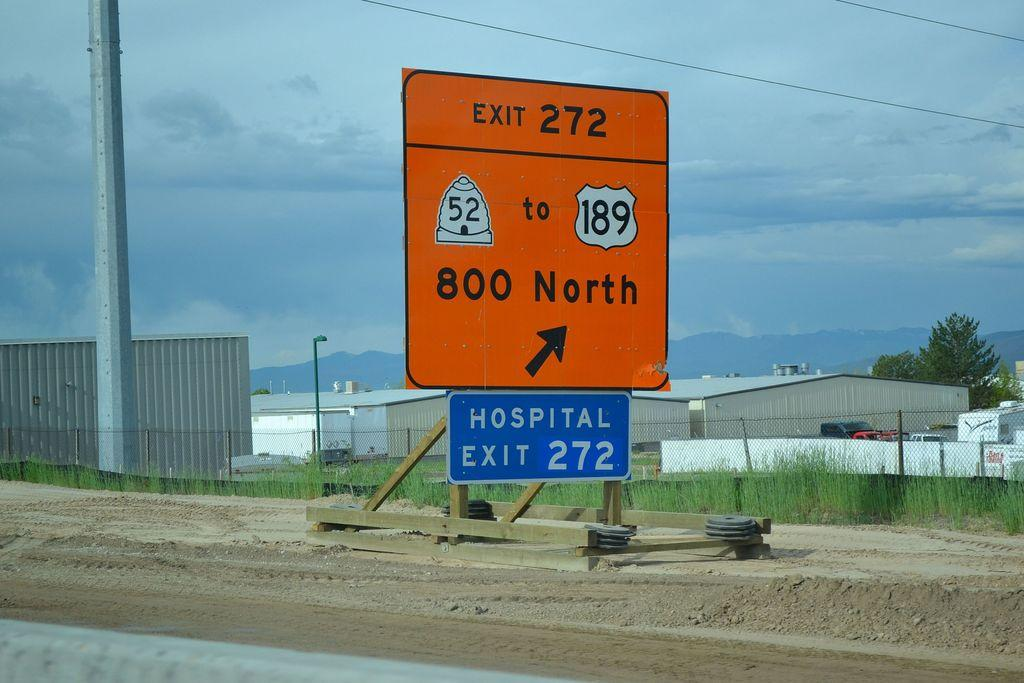<image>
Present a compact description of the photo's key features. A road sign showing that the hospital can be found on exit 272. 